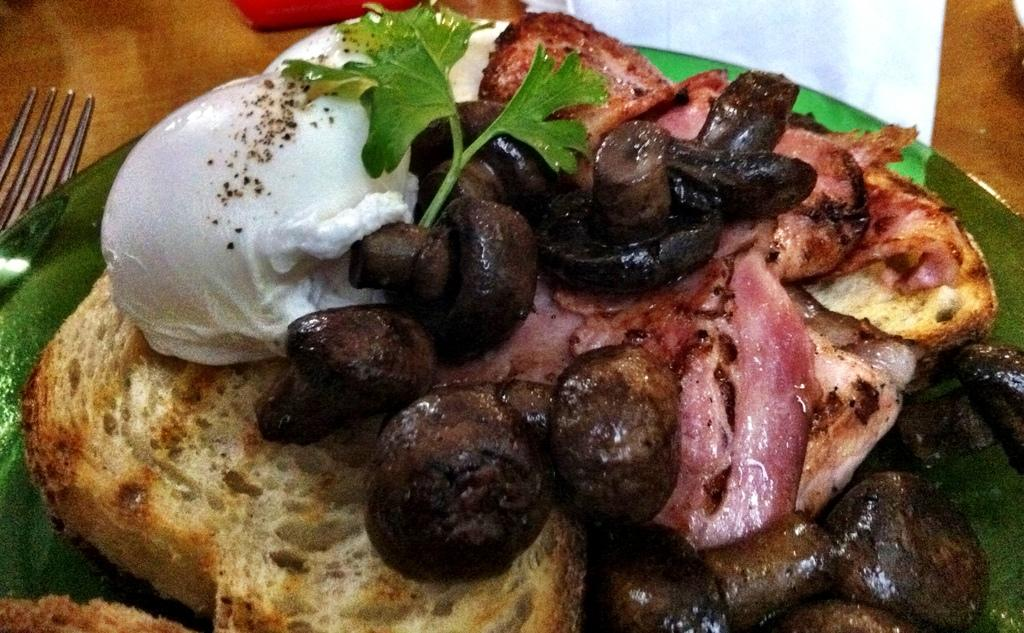What is on the plate that is visible in the image? There is a plate with food in the image, specifically two scoops of ice cream. What utensil is present on the table in the image? There is a fork on the table in the image. What else can be seen on the table besides the fork? There are other objects on the table, but their specific details are not mentioned in the provided facts. What type of wire is holding the chickens in the image? There are no chickens or wire present in the image; it features a plate with food and a fork on the table. 